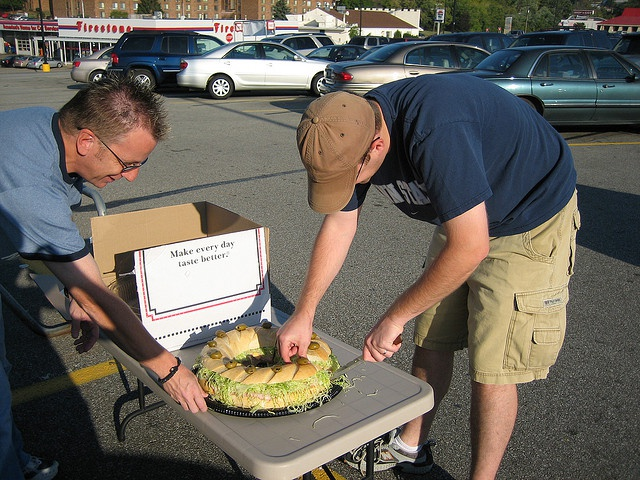Describe the objects in this image and their specific colors. I can see people in black, navy, tan, and gray tones, people in black, gray, and brown tones, car in black, blue, teal, and darkblue tones, sandwich in black, khaki, and tan tones, and car in black, white, darkgray, and gray tones in this image. 